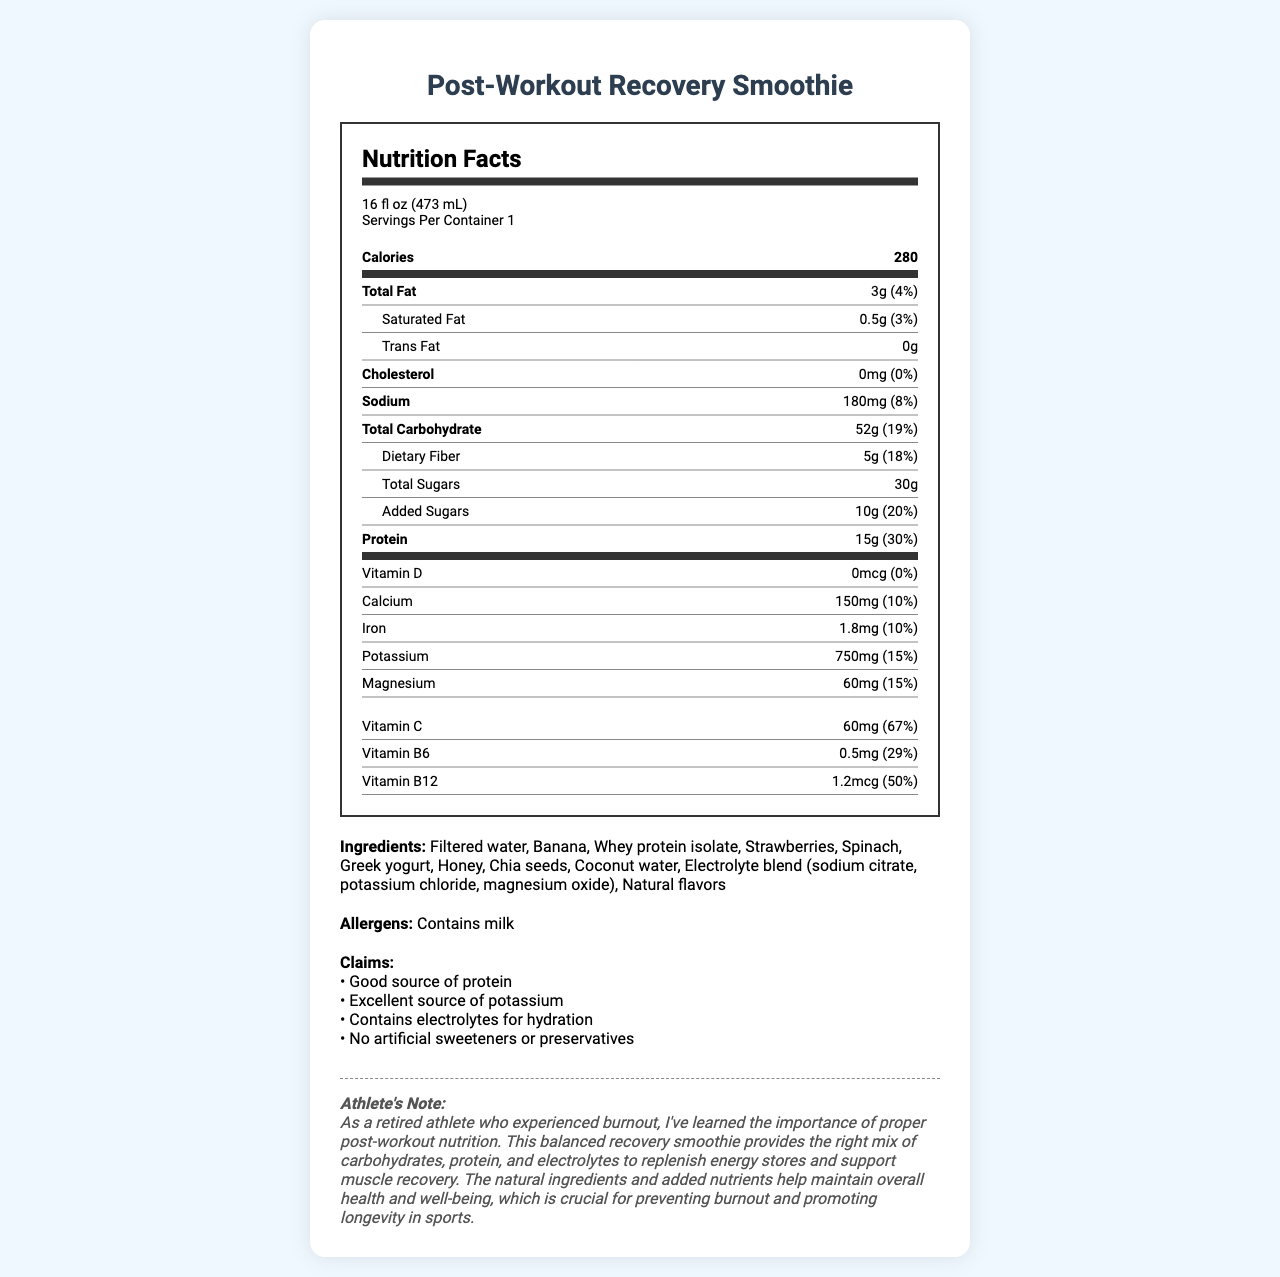what is the serving size for the smoothie? The serving size is explicitly listed at the top of the nutrition facts section.
Answer: 16 fl oz (473 mL) how much protein does one serving provide? The amount of protein per serving is specified as 15g.
Answer: 15g what percentage of the daily value of vitamin C does this smoothie provide? Under the vitamins section, the daily value for vitamin C is listed as 67%.
Answer: 67% what ingredient provides the added electrolytes? The ingredient list includes an electrolyte blend that consists of sodium citrate, potassium chloride, and magnesium oxide.
Answer: Electrolyte blend (sodium citrate, potassium chloride, magnesium oxide) how does the smoothie support hydration? The claims section states that the smoothie contains electrolytes for hydration.
Answer: Contains electrolytes for hydration which nutrient has the highest daily value percentage in this smoothie? A. Vitamin C B. Potassium C. Protein D. Vitamin B12 Vitamin C has a daily value percentage of 67%, which is higher than the other listed nutrients.
Answer: A what are the ingredients used in this smoothie? The ingredients are listed at the bottom of the document.
Answer: Filtered water, Banana, Whey protein isolate, Strawberries, Spinach, Greek yogurt, Honey, Chia seeds, Coconut water, Electrolyte blend (sodium citrate, potassium chloride, magnesium oxide), Natural flavors are there any allergens present in the smoothie? The allergens section indicates that the smoothie contains milk.
Answer: Yes how much calcium is in the smoothie? The amount of calcium is specified as 150mg in the nutrition facts section.
Answer: 150mg which claims are made about this smoothie? A. Contains electrolytes B. Good source of vitamins C. Contains artificial sweeteners The claims do not mention artificial sweeteners or vitamins explicitly; they do state the smoothie contains electrolytes.
Answer: A does the smoothie contain any trans fat? The nutrition facts section confirms that the smoothie contains 0g of trans fat.
Answer: No what is the main idea of the document? The document includes sections on serving size, nutritional content, ingredients, allergens, and specific health claims and notes on the benefits of the smoothie.
Answer: The document provides detailed nutrition facts for a balanced post-workout recovery smoothie, emphasizing its benefits for hydration, muscle recovery, and overall health, incorporating natural ingredients and added electrolytes. how much total carbohydrate is in one serving? The total carbohydrate content is listed as 52g in the nutrition facts section.
Answer: 52g what is the purpose of this smoothie as stated in the athlete's note? The athlete's note at the end of the document explains the purpose of the smoothie, which is to replenish energy, aid in muscle recovery, and contribute to overall health and well-being.
Answer: To replenish energy stores and support muscle recovery, helping maintain overall health and prevent burnout. does this smoothie include any artificial ingredients like sweeteners or preservatives? The claims section explicitly states that there are no artificial sweeteners or preservatives in the smoothie.
Answer: No how much sodium does the smoothie contain? The sodium content is specified as 180mg in the nutrition facts section.
Answer: 180mg what is the daily value percentage of added sugars in this smoothie? The daily value for added sugars is listed at 20%.
Answer: 20% what makes this smoothie an excellent source of potassium? The nutrition facts section indicates that this amount fulfills 15% of the daily value, qualifying it as an excellent source.
Answer: It provides 750mg of potassium, which is 15% of the daily value. how much vitamin D is in this smoothie? The amount of vitamin D is listed as 0mcg in the nutrition facts section.
Answer: 0mcg how can the presence of milk affect people with allergies? The allergens section clearly indicates that the smoothie contains milk, making it unsuitable for those with milk allergies.
Answer: People with milk allergies should avoid this smoothie as it contains milk. 